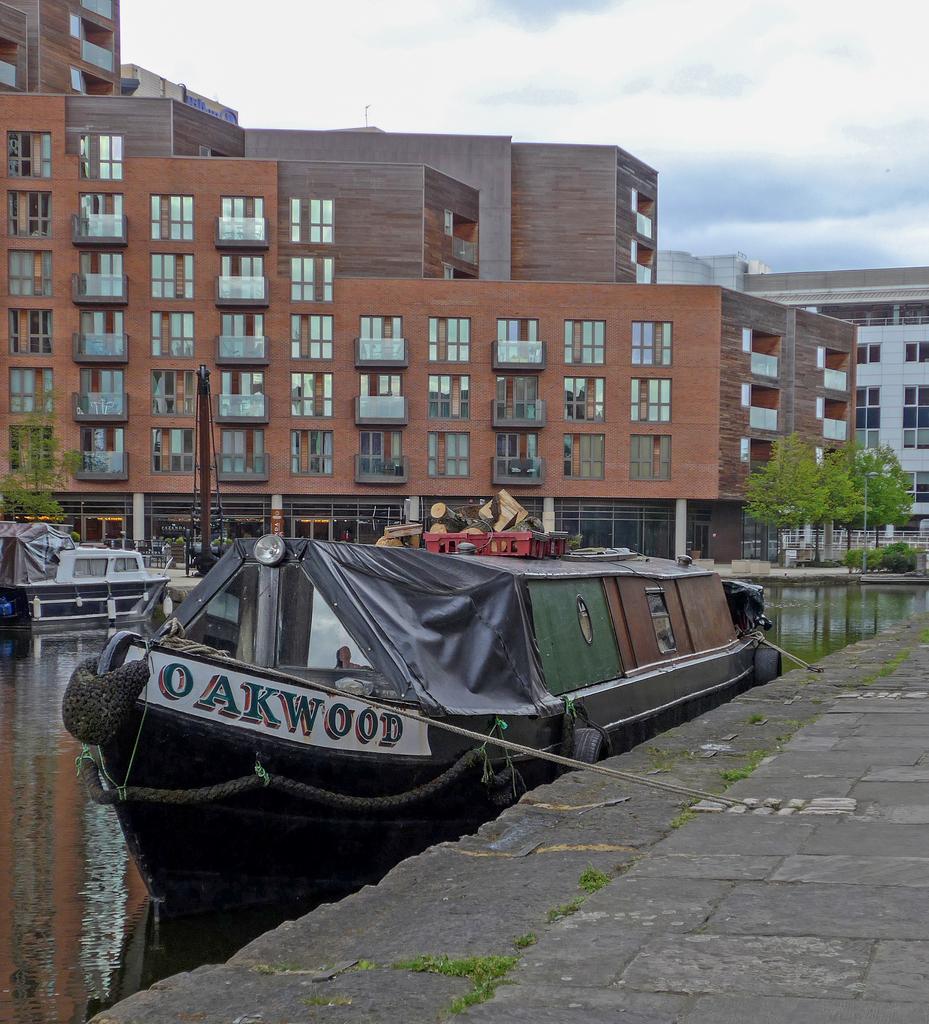In one or two sentences, can you explain what this image depicts? In the picture we can see a path beside it, we can see a boat in the water, which is black in color and name to it as Oak wood and beside the boat we can see another boat and behind it, we can see some plants and a huge building which is brown in color with many windows and glasses to it and beside it we can see some other buildings and near it also we can see some plants and in the background we can see a sky with clouds. 